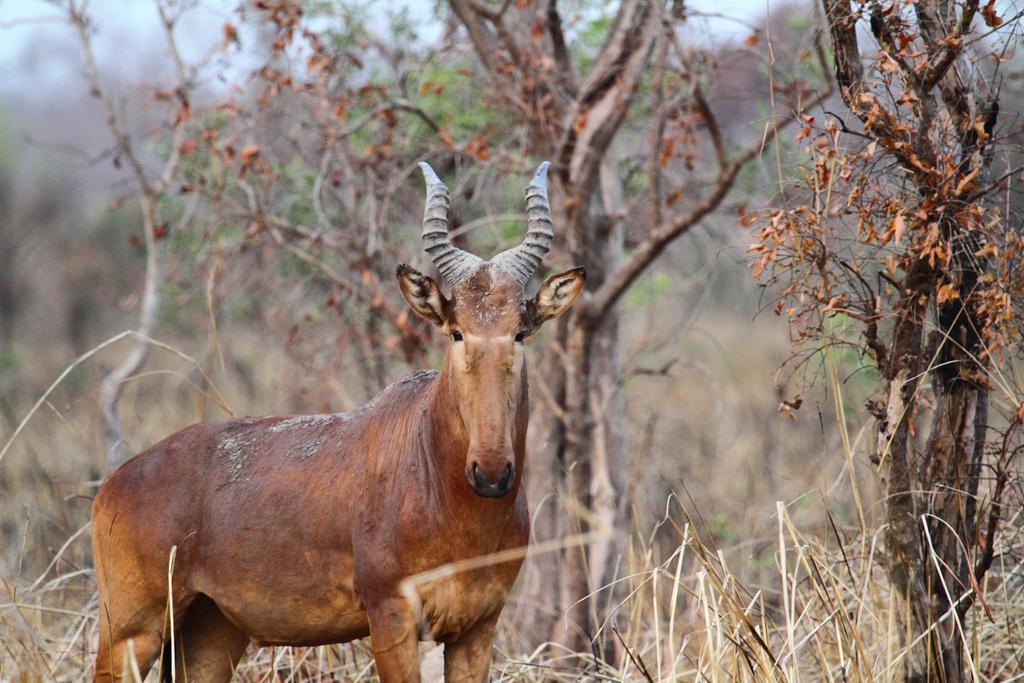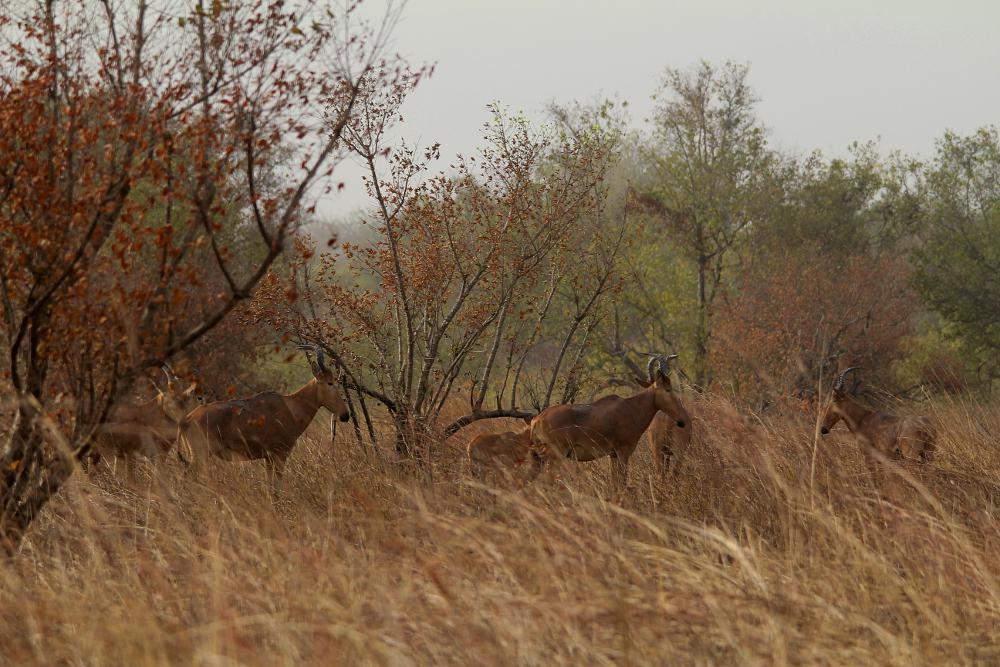The first image is the image on the left, the second image is the image on the right. For the images shown, is this caption "In at least one image, animals are drinking water." true? Answer yes or no. No. 